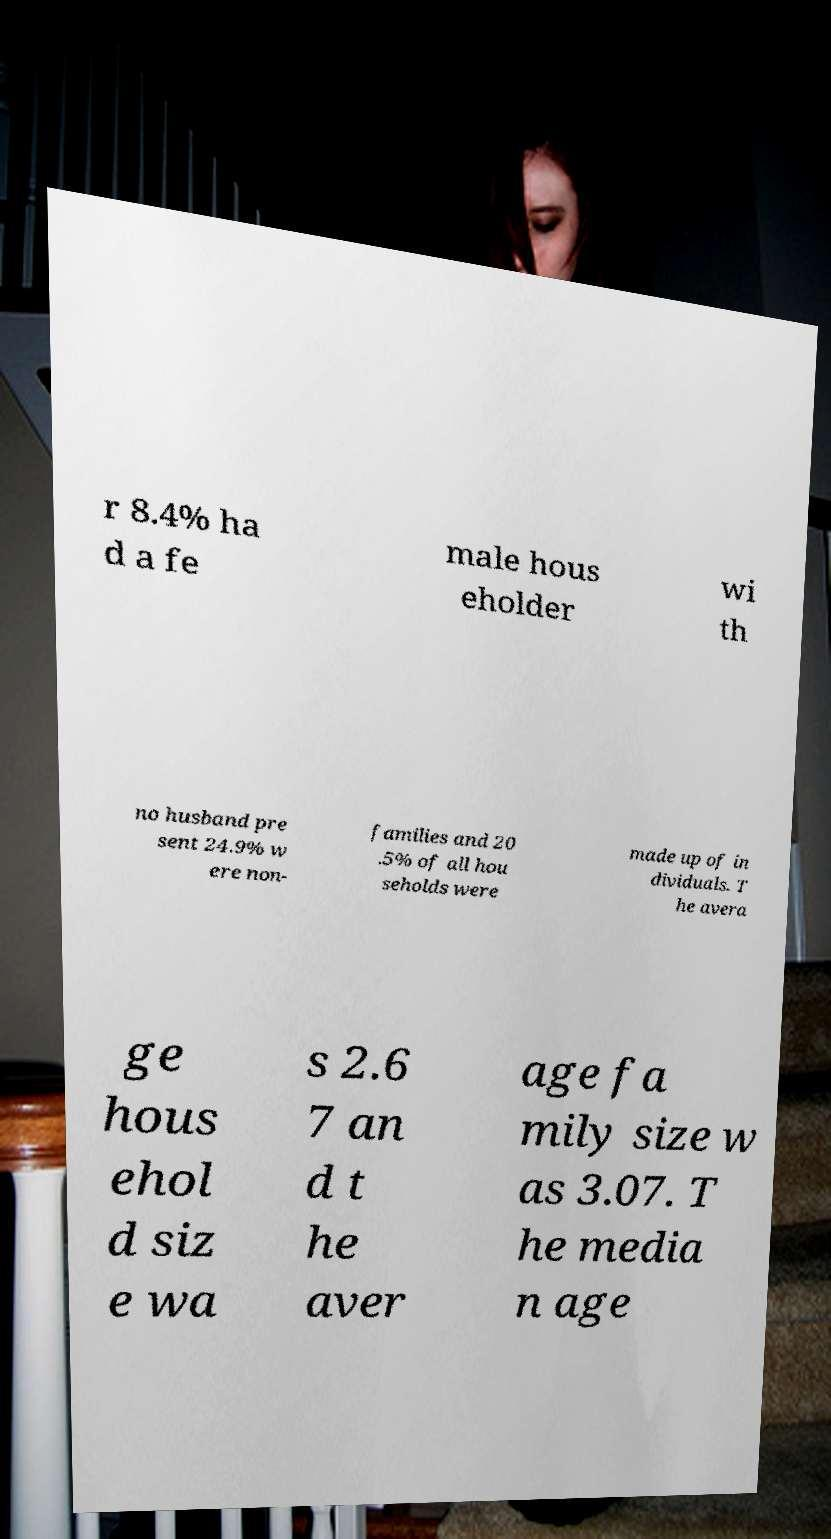What messages or text are displayed in this image? I need them in a readable, typed format. r 8.4% ha d a fe male hous eholder wi th no husband pre sent 24.9% w ere non- families and 20 .5% of all hou seholds were made up of in dividuals. T he avera ge hous ehol d siz e wa s 2.6 7 an d t he aver age fa mily size w as 3.07. T he media n age 